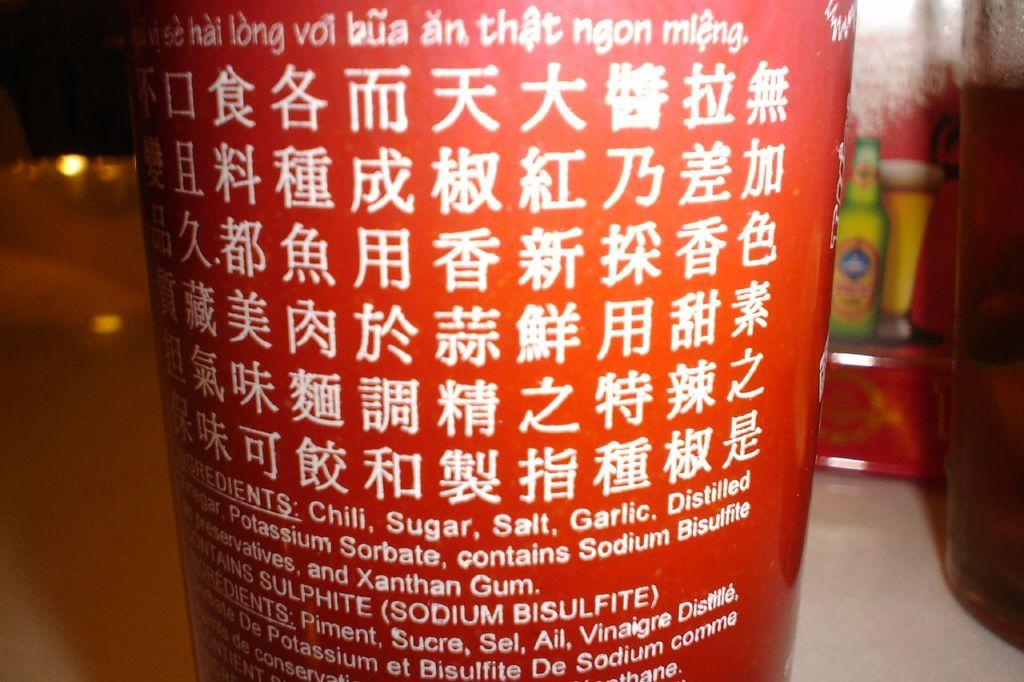<image>
Present a compact description of the photo's key features. A jar or bottle lists the ingredients that include chili, sugar, salt, garlic and sodium bisulfite. 